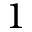Convert formula to latex. <formula><loc_0><loc_0><loc_500><loc_500>1</formula> 